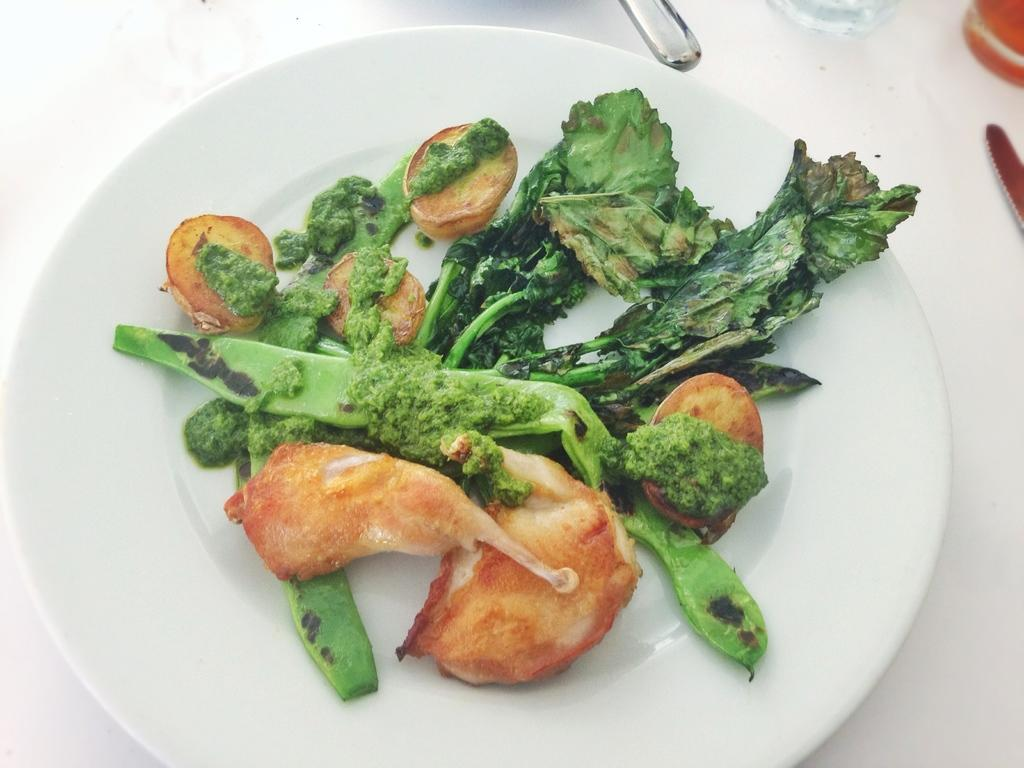What is on the plate that is visible in the image? There is food on a plate in the image. What other objects can be seen on the white surface? There are no other objects mentioned on the white surface in the provided facts. How many roses are present on the plate in the image? There is no mention of roses on the plate in the provided facts. What is the purpose of the knee in the image? There is no mention of a knee in the provided facts, so it is not possible to determine its purpose in the image. 